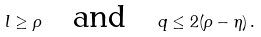<formula> <loc_0><loc_0><loc_500><loc_500>l \geq \rho \quad \text {and} \quad q \leq 2 ( \rho - \eta ) \, .</formula> 